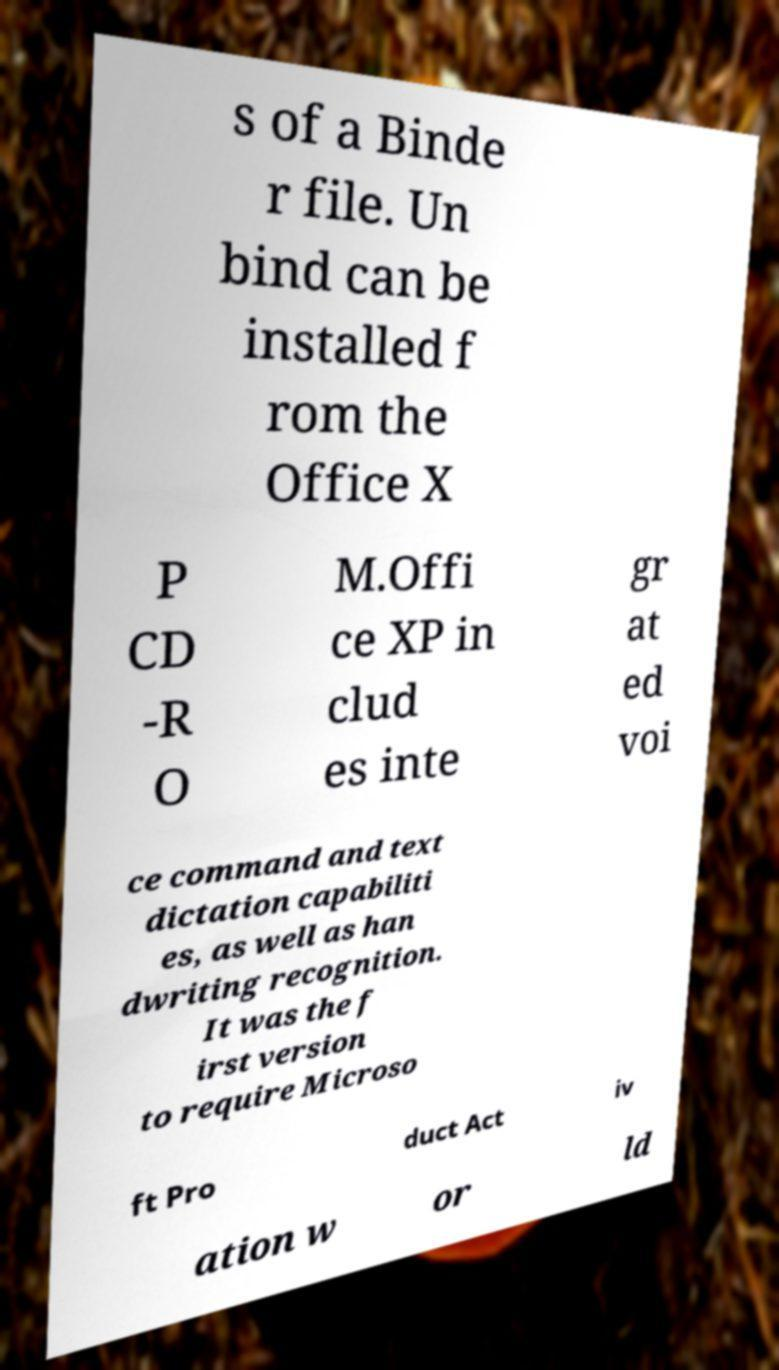What messages or text are displayed in this image? I need them in a readable, typed format. s of a Binde r file. Un bind can be installed f rom the Office X P CD -R O M.Offi ce XP in clud es inte gr at ed voi ce command and text dictation capabiliti es, as well as han dwriting recognition. It was the f irst version to require Microso ft Pro duct Act iv ation w or ld 